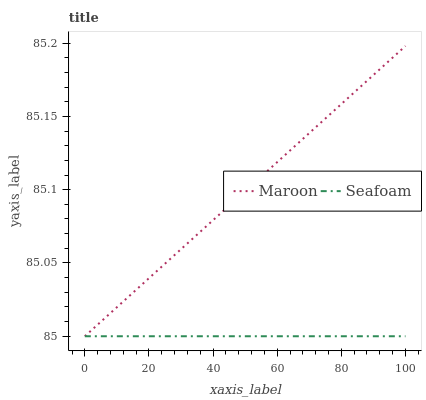Does Maroon have the minimum area under the curve?
Answer yes or no. No. Is Maroon the smoothest?
Answer yes or no. No. 